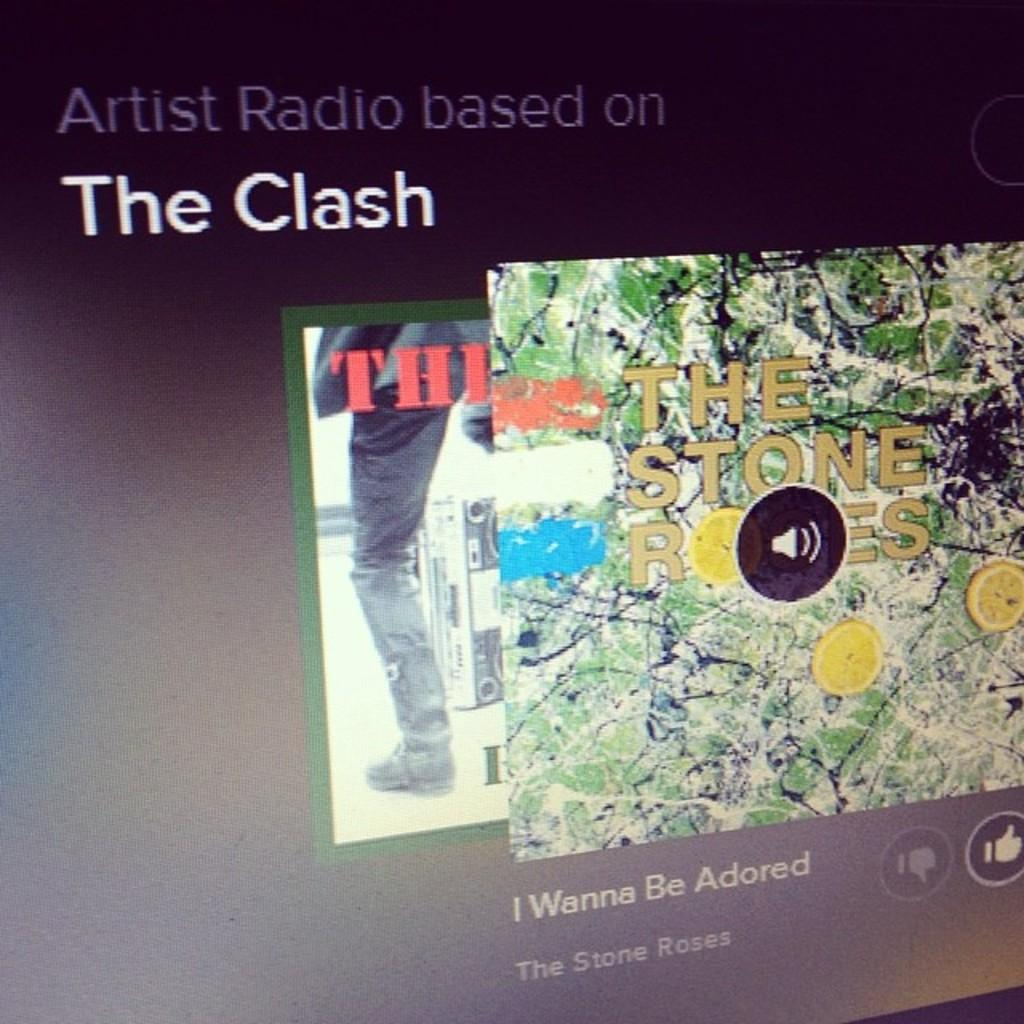Provide a one-sentence caption for the provided image. A radio station based on The Clash is playing a song by The Stone Roses. 